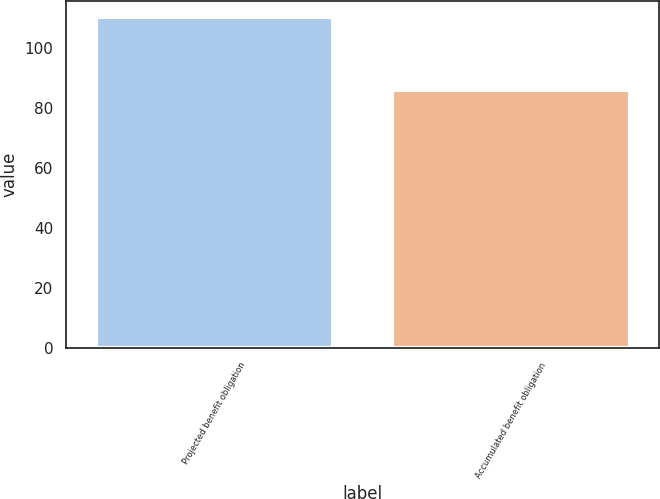<chart> <loc_0><loc_0><loc_500><loc_500><bar_chart><fcel>Projected benefit obligation<fcel>Accumulated benefit obligation<nl><fcel>110.3<fcel>86.1<nl></chart> 